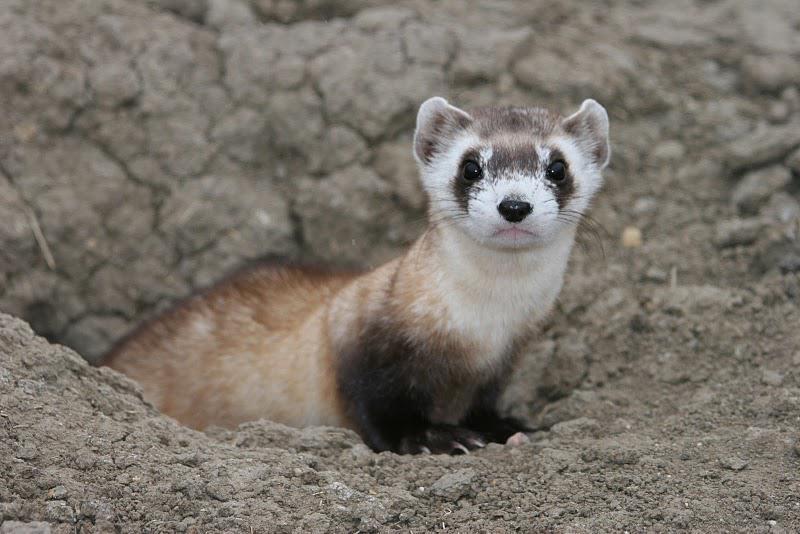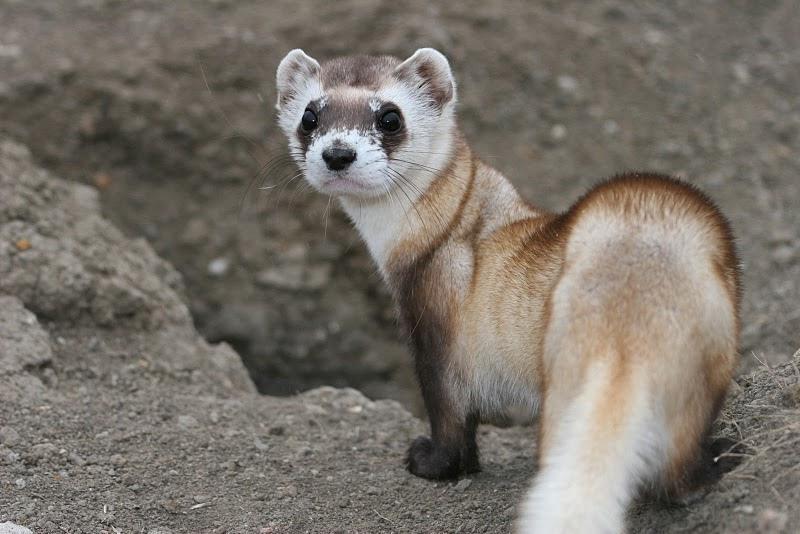The first image is the image on the left, the second image is the image on the right. Evaluate the accuracy of this statement regarding the images: "An image shows a camera-facing ferret emerging from a hole in the ground.". Is it true? Answer yes or no. Yes. The first image is the image on the left, the second image is the image on the right. Evaluate the accuracy of this statement regarding the images: "Two animals are standing on the dirt in one of the images.". Is it true? Answer yes or no. No. 